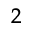<formula> <loc_0><loc_0><loc_500><loc_500>^ { 2 }</formula> 